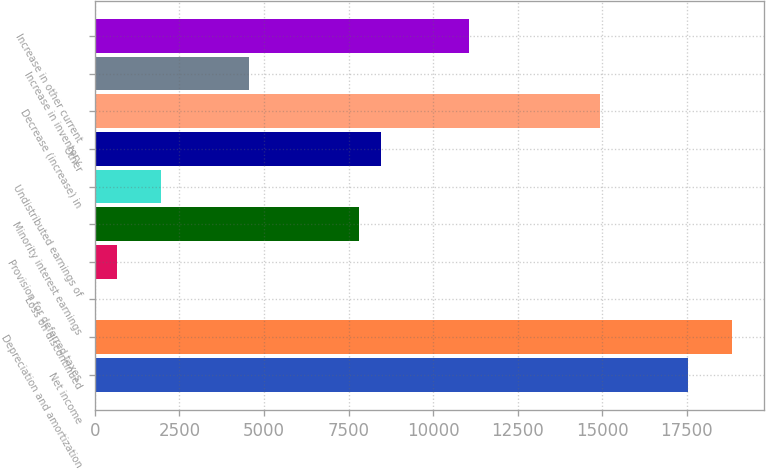<chart> <loc_0><loc_0><loc_500><loc_500><bar_chart><fcel>Net income<fcel>Depreciation and amortization<fcel>Loss on discontinued<fcel>Provision for deferred taxes<fcel>Minority interest earnings<fcel>Undistributed earnings of<fcel>Other<fcel>Decrease (increase) in<fcel>Increase in inventory<fcel>Increase in other current<nl><fcel>17545.9<fcel>18845.3<fcel>4<fcel>653.7<fcel>7800.4<fcel>1953.1<fcel>8450.1<fcel>14947.1<fcel>4551.9<fcel>11048.9<nl></chart> 